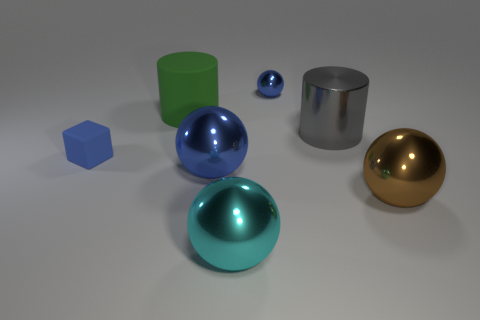What is the shape of the big brown thing?
Keep it short and to the point. Sphere. How big is the blue metal sphere that is left of the large cyan metal object?
Provide a succinct answer. Large. There is another cylinder that is the same size as the shiny cylinder; what is its color?
Offer a very short reply. Green. Are there any objects of the same color as the large rubber cylinder?
Make the answer very short. No. Are there fewer blue balls that are in front of the large gray object than large brown spheres that are behind the green object?
Keep it short and to the point. No. The object that is to the left of the big blue metal ball and in front of the gray cylinder is made of what material?
Ensure brevity in your answer.  Rubber. Does the small metal thing have the same shape as the metallic object that is in front of the big brown ball?
Provide a succinct answer. Yes. What number of other things are there of the same size as the cyan thing?
Your answer should be compact. 4. Are there more matte cubes than cylinders?
Make the answer very short. No. How many big things are both behind the tiny block and in front of the green object?
Make the answer very short. 1. 